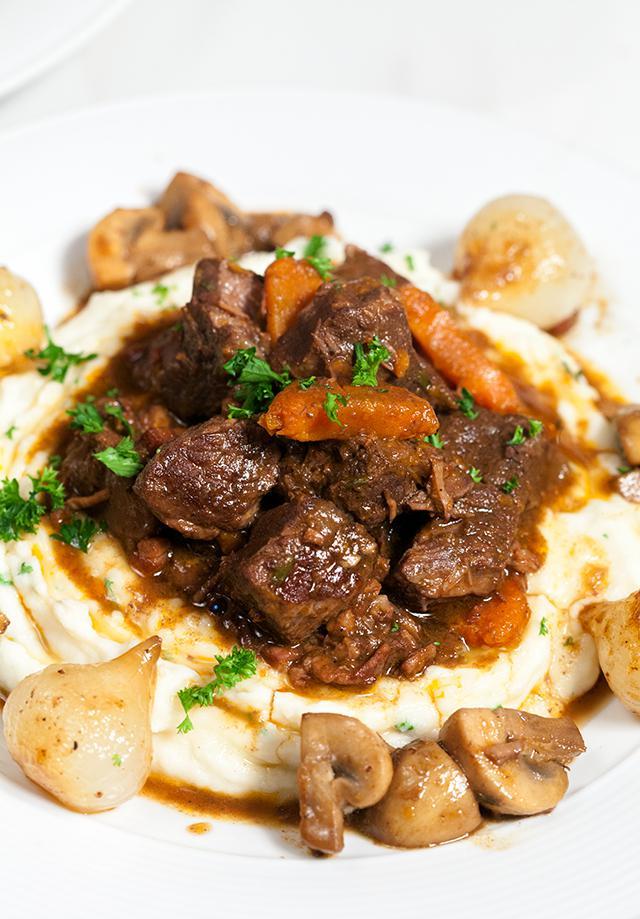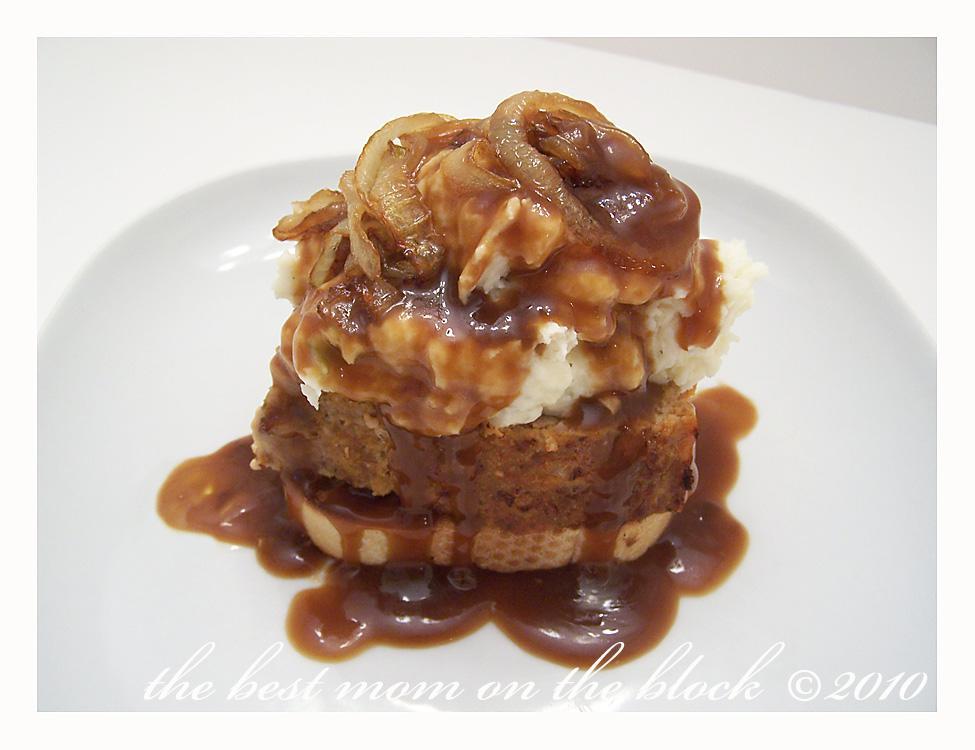The first image is the image on the left, the second image is the image on the right. Examine the images to the left and right. Is the description "A dish includes meatloaf topped with mashed potatoes and brown gravy." accurate? Answer yes or no. Yes. The first image is the image on the left, the second image is the image on the right. Analyze the images presented: Is the assertion "There is nothing on top of a mashed potato in the right image." valid? Answer yes or no. No. 